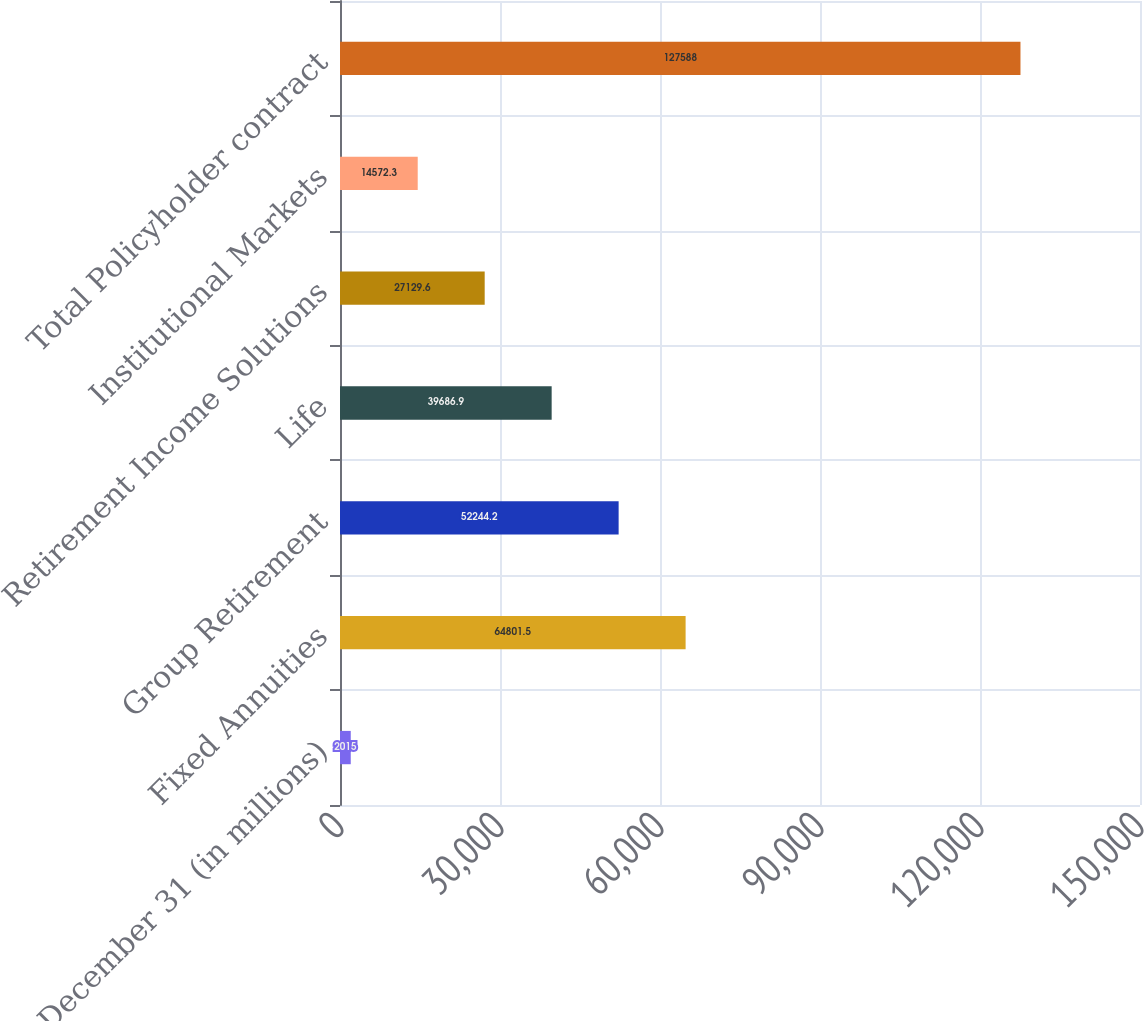<chart> <loc_0><loc_0><loc_500><loc_500><bar_chart><fcel>At December 31 (in millions)<fcel>Fixed Annuities<fcel>Group Retirement<fcel>Life<fcel>Retirement Income Solutions<fcel>Institutional Markets<fcel>Total Policyholder contract<nl><fcel>2015<fcel>64801.5<fcel>52244.2<fcel>39686.9<fcel>27129.6<fcel>14572.3<fcel>127588<nl></chart> 